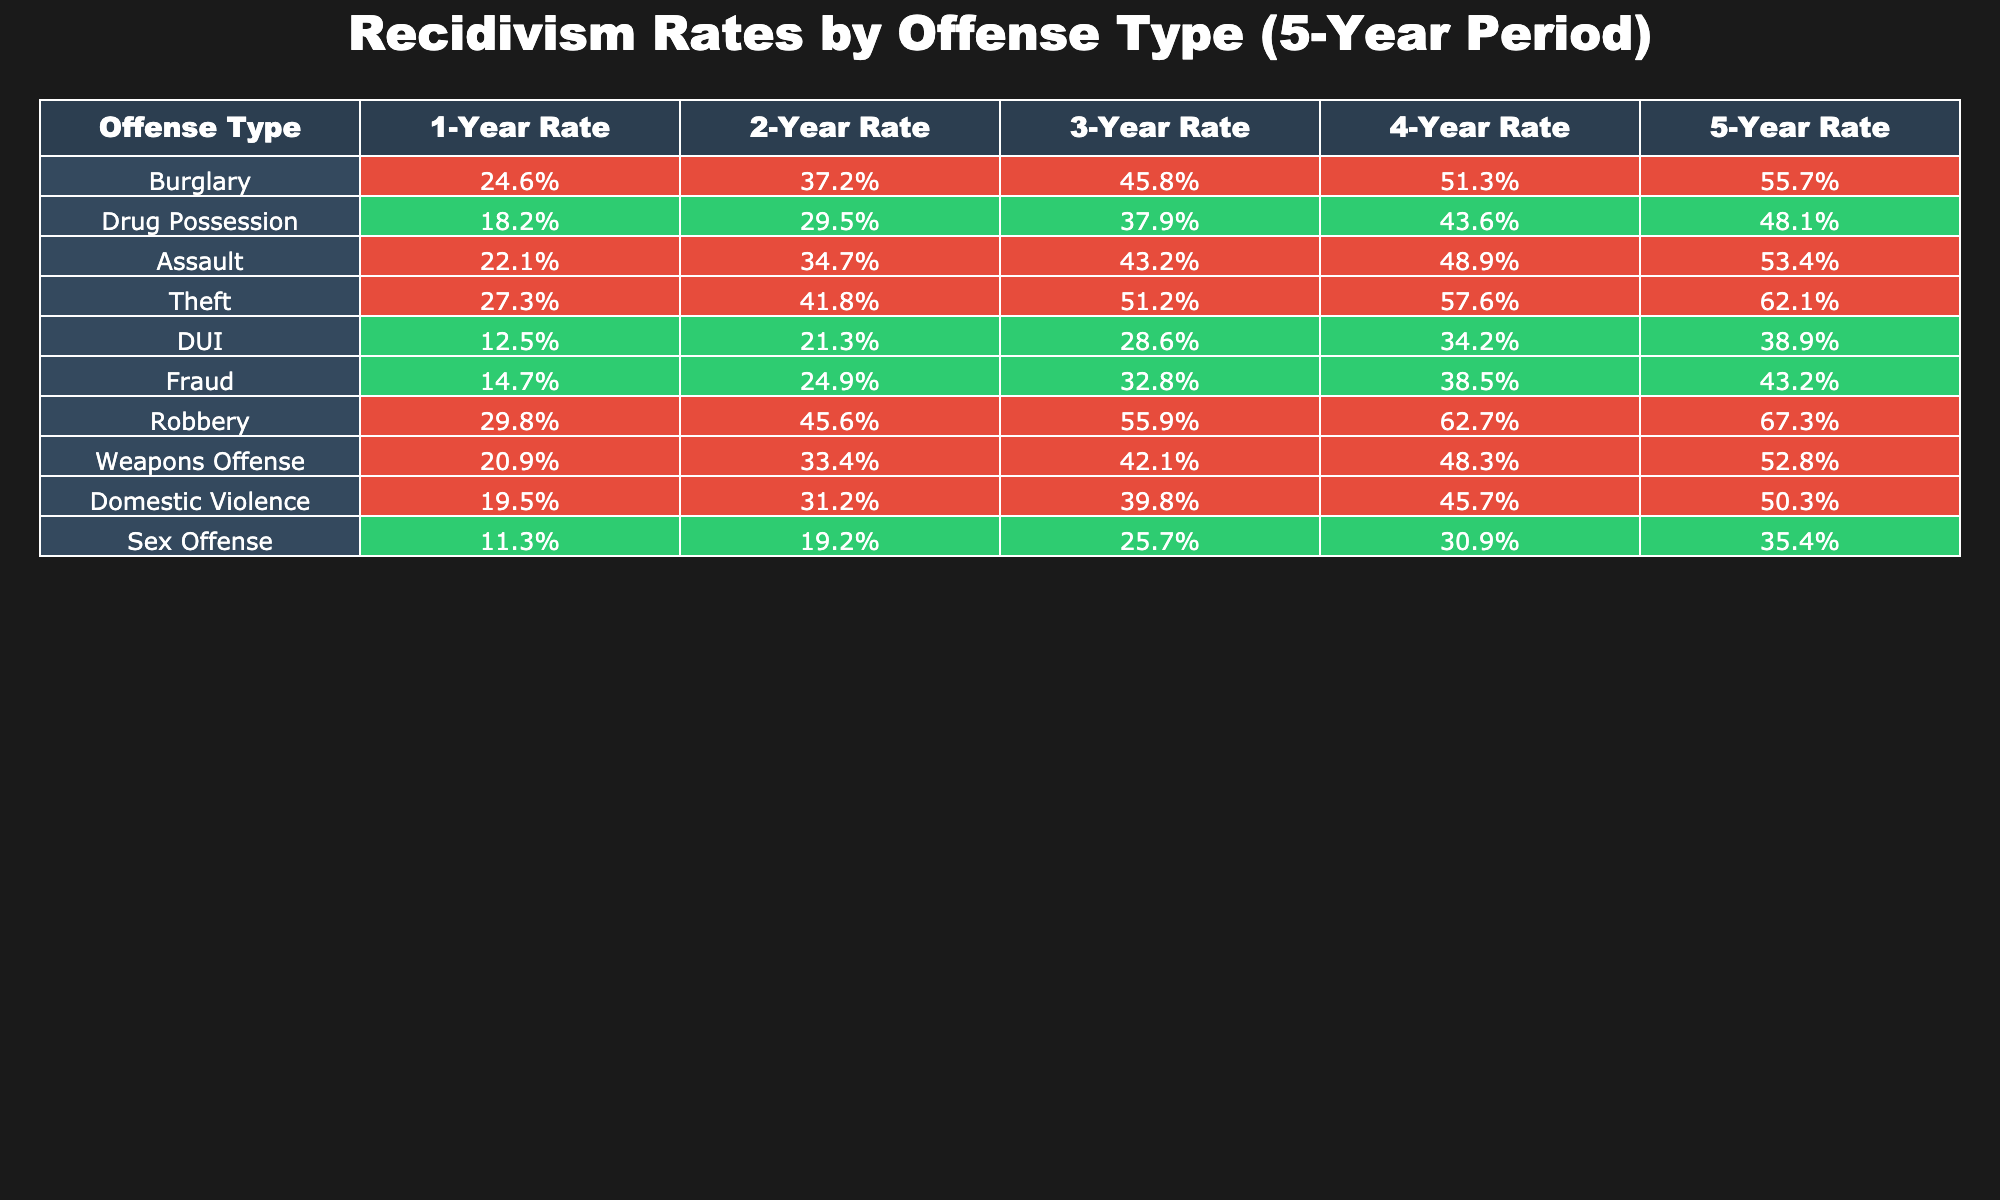What is the recidivism rate for burglary after 5 years? The table shows that the 5-Year Rate for burglary is 55.7%.
Answer: 55.7% Which offense type has the highest 1-Year recidivism rate? From the table, the offense type with the highest 1-Year Rate is robbery, which is 29.8%.
Answer: Robbery What is the difference in recidivism rates between DUI and domestic violence offenses after 4 years? The 4-Year Rate for DUI is 34.2%, and for domestic violence, it is 45.7%. The difference is calculated as 45.7% - 34.2% = 11.5%.
Answer: 11.5% Is the 3-Year recidivism rate for theft higher than that for drug possession? The table shows the 3-Year Rate for theft is 51.2%, while for drug possession, it is 37.9%. Since 51.2% is greater than 37.9%, the answer is yes.
Answer: Yes What is the average recidivism rate after 5 years across all offense types? First, sum the 5-Year Rates: 55.7 + 48.1 + 53.4 + 62.1 + 38.9 + 43.2 + 67.3 + 52.8 + 50.3 + 35.4 = 468.8%. Then, divide by the number of offense types, which is 10: 468.8% / 10 = 46.88%.
Answer: 46.88% What percentage of offenders recidivated after 2 years for sex offenses? The table indicates that the 2-Year Rate for sex offenses is 19.2%.
Answer: 19.2% Which two offense types have the most similar 5-Year recidivism rates? By examining the 5-Year Rates, drug possession (48.1%) and domestic violence (50.3%) are the closest together. The difference is 2.2%.
Answer: Drug Possession and Domestic Violence Is the recidivism rate for fraud after 1 year greater than that for DUI? Fraud has a 1-Year Rate of 14.7%, while DUI has 12.5%. Since 14.7% is greater than 12.5%, the answer is yes.
Answer: Yes What is the cumulative increase in the recidivism rate for assault from year 1 to year 5? The 1-Year Rate for assault is 22.1%, and the 5-Year Rate is 53.4%. The cumulative increase is 53.4% - 22.1% = 31.3%.
Answer: 31.3% Which offense type shows the smallest increase in its recidivism rate from year 1 to year 5? By analyzing the increases, DUI has an increase from 12.5% (year 1) to 38.9% (year 5), which is 26.4%. All others have greater increases, so DUI has the smallest increase.
Answer: DUI 